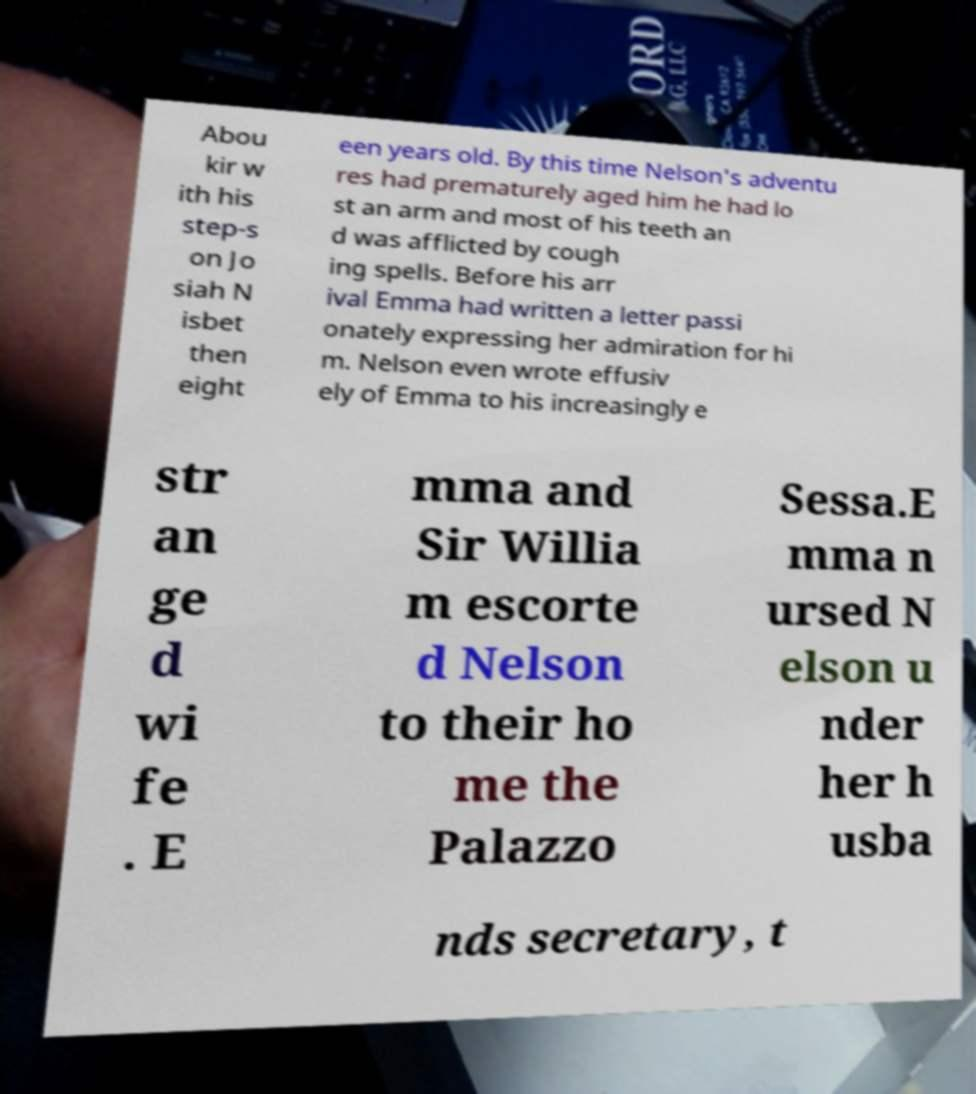Could you extract and type out the text from this image? Abou kir w ith his step-s on Jo siah N isbet then eight een years old. By this time Nelson's adventu res had prematurely aged him he had lo st an arm and most of his teeth an d was afflicted by cough ing spells. Before his arr ival Emma had written a letter passi onately expressing her admiration for hi m. Nelson even wrote effusiv ely of Emma to his increasingly e str an ge d wi fe . E mma and Sir Willia m escorte d Nelson to their ho me the Palazzo Sessa.E mma n ursed N elson u nder her h usba nds secretary, t 